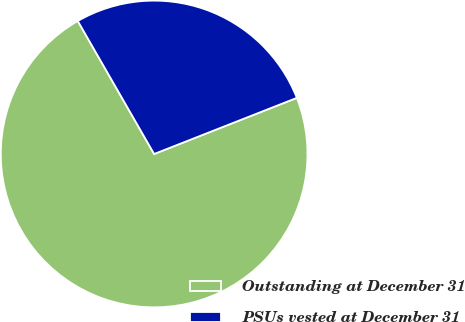Convert chart to OTSL. <chart><loc_0><loc_0><loc_500><loc_500><pie_chart><fcel>Outstanding at December 31<fcel>PSUs vested at December 31<nl><fcel>72.67%<fcel>27.33%<nl></chart> 